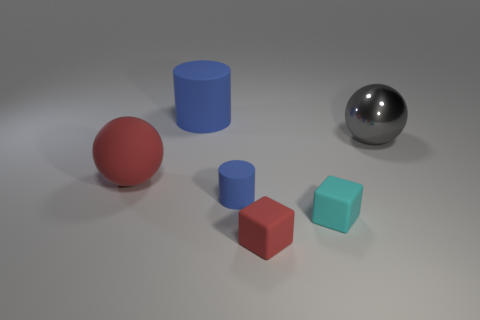How would you describe the different colors present in the image? The image features primary and secondary colors with a muted tone. We have a rich blue, a subtle red, and a pastel turquoise alongside a neutral gray sphere, all set against a light gray background. Each color is solid, lacking texture or pattern, which emphasizes the geometry of the objects. 